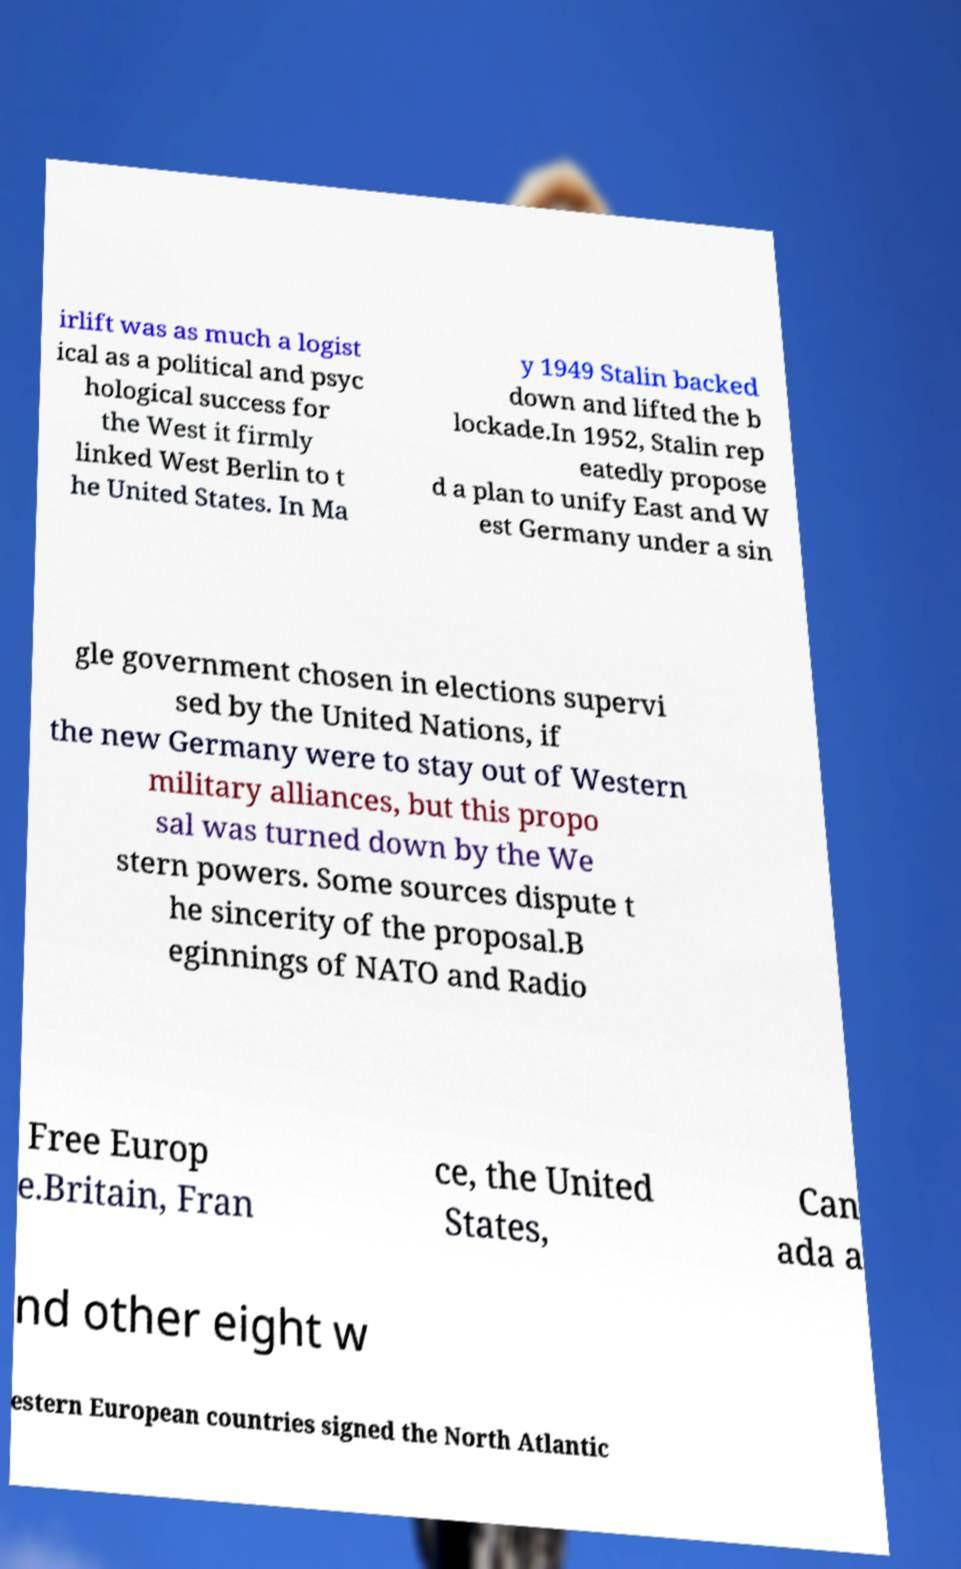Could you assist in decoding the text presented in this image and type it out clearly? irlift was as much a logist ical as a political and psyc hological success for the West it firmly linked West Berlin to t he United States. In Ma y 1949 Stalin backed down and lifted the b lockade.In 1952, Stalin rep eatedly propose d a plan to unify East and W est Germany under a sin gle government chosen in elections supervi sed by the United Nations, if the new Germany were to stay out of Western military alliances, but this propo sal was turned down by the We stern powers. Some sources dispute t he sincerity of the proposal.B eginnings of NATO and Radio Free Europ e.Britain, Fran ce, the United States, Can ada a nd other eight w estern European countries signed the North Atlantic 